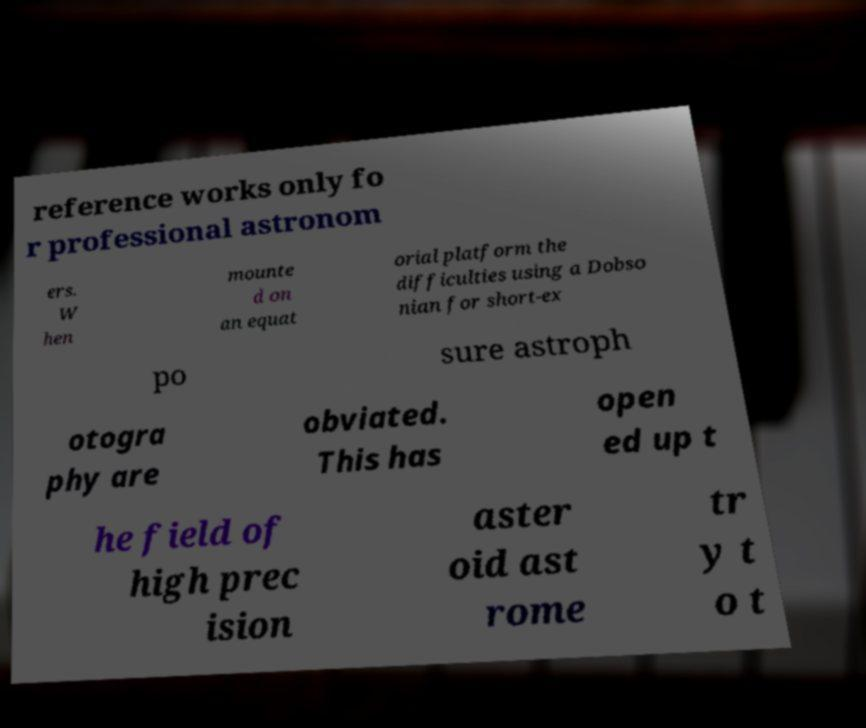There's text embedded in this image that I need extracted. Can you transcribe it verbatim? reference works only fo r professional astronom ers. W hen mounte d on an equat orial platform the difficulties using a Dobso nian for short-ex po sure astroph otogra phy are obviated. This has open ed up t he field of high prec ision aster oid ast rome tr y t o t 